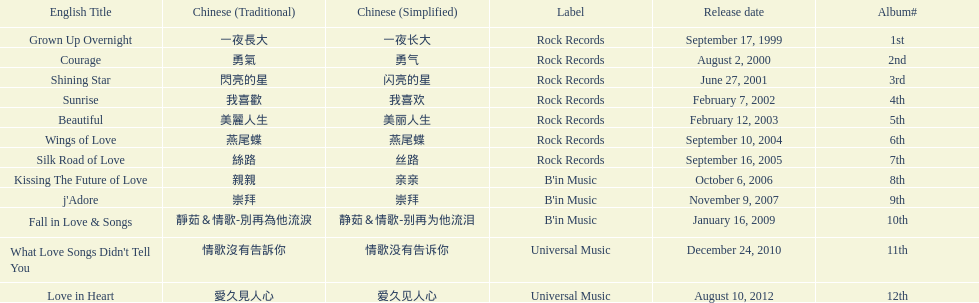What is the number of songs on rock records? 7. 